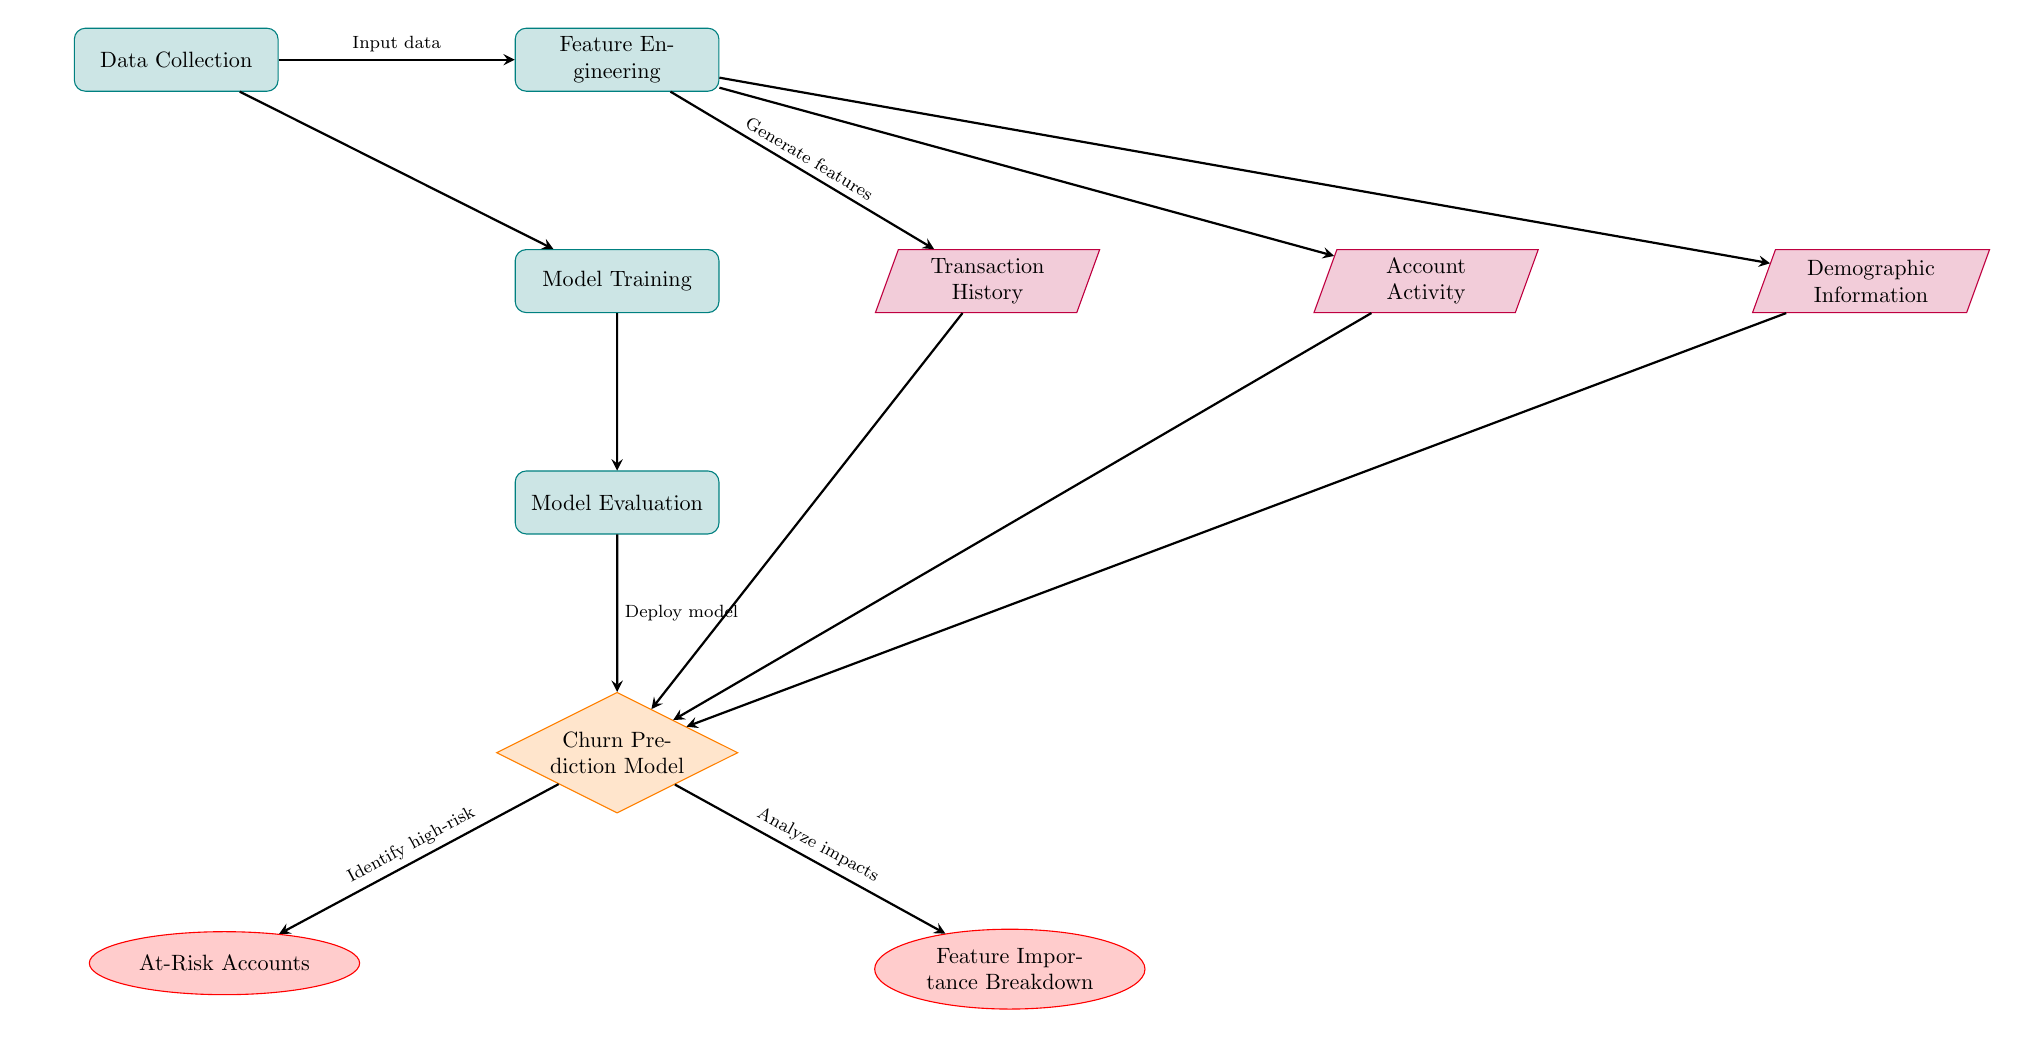What is the first process in the diagram? The first process node in the diagram is labeled 'Data Collection', indicating that data collection is the initial step in the workflow.
Answer: Data Collection How many data nodes are present in the diagram? The diagram contains three data nodes: 'Transaction History', 'Account Activity', and 'Demographic Information'. Counting these nodes results in three.
Answer: Three What is the output of the 'Churn Prediction Model'? The 'Churn Prediction Model' produces two outputs: 'At-Risk Accounts' and 'Feature Importance Breakdown', both indicated as outputs stemming from this model.
Answer: At-Risk Accounts and Feature Importance Breakdown What process follows 'Model Training'? According to the arrows in the diagram, 'Model Evaluation' directly follows 'Model Training', indicating the sequential steps of the workflow.
Answer: Model Evaluation Which node receives input from 'Feature Engineering'? The 'Churn Prediction Model' receives input from 'Feature Engineering', as indicated by the directed arrow leading from 'Feature Engineering' to 'Churn Prediction Model'.
Answer: Churn Prediction Model How many distinct outputs are linked to the 'Churn Prediction Model'? The 'Churn Prediction Model' links to two distinct outputs: 'At-Risk Accounts' and 'Feature Importance Breakdown', so the number of outputs is two.
Answer: Two What is the purpose of the 'Feature Importance Breakdown' output? The purpose of the 'Feature Importance Breakdown' output is to analyze the impacts of various features in predicting churn, as indicated in the diagram's labels.
Answer: Analyze impacts Which step does the 'Model Evaluation' process lead to? The 'Model Evaluation' process leads to the 'Churn Prediction Model', indicating that model evaluation is necessary for deploying the model.
Answer: Churn Prediction Model What relationship exists between 'Transaction History' and 'Churn Prediction Model'? The 'Churn Prediction Model' receives input from 'Transaction History', establishing a direct input-output relationship between these two nodes.
Answer: Input-output relationship 